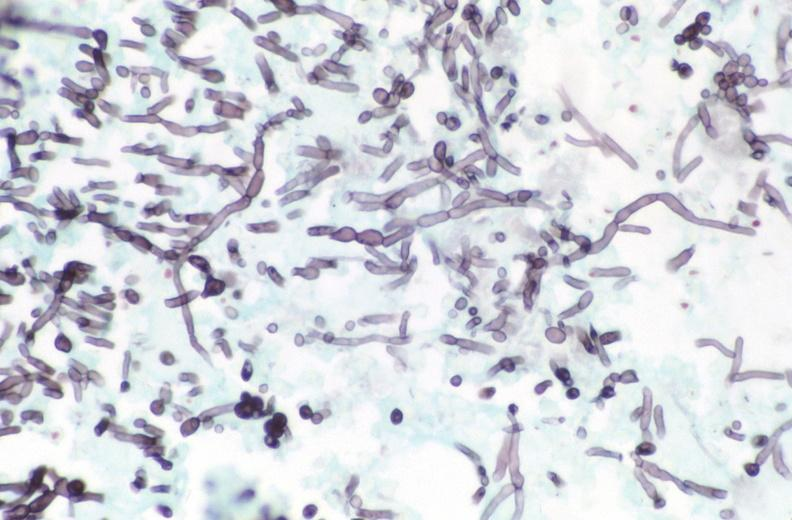where is this from?
Answer the question using a single word or phrase. Gastrointestinal system 